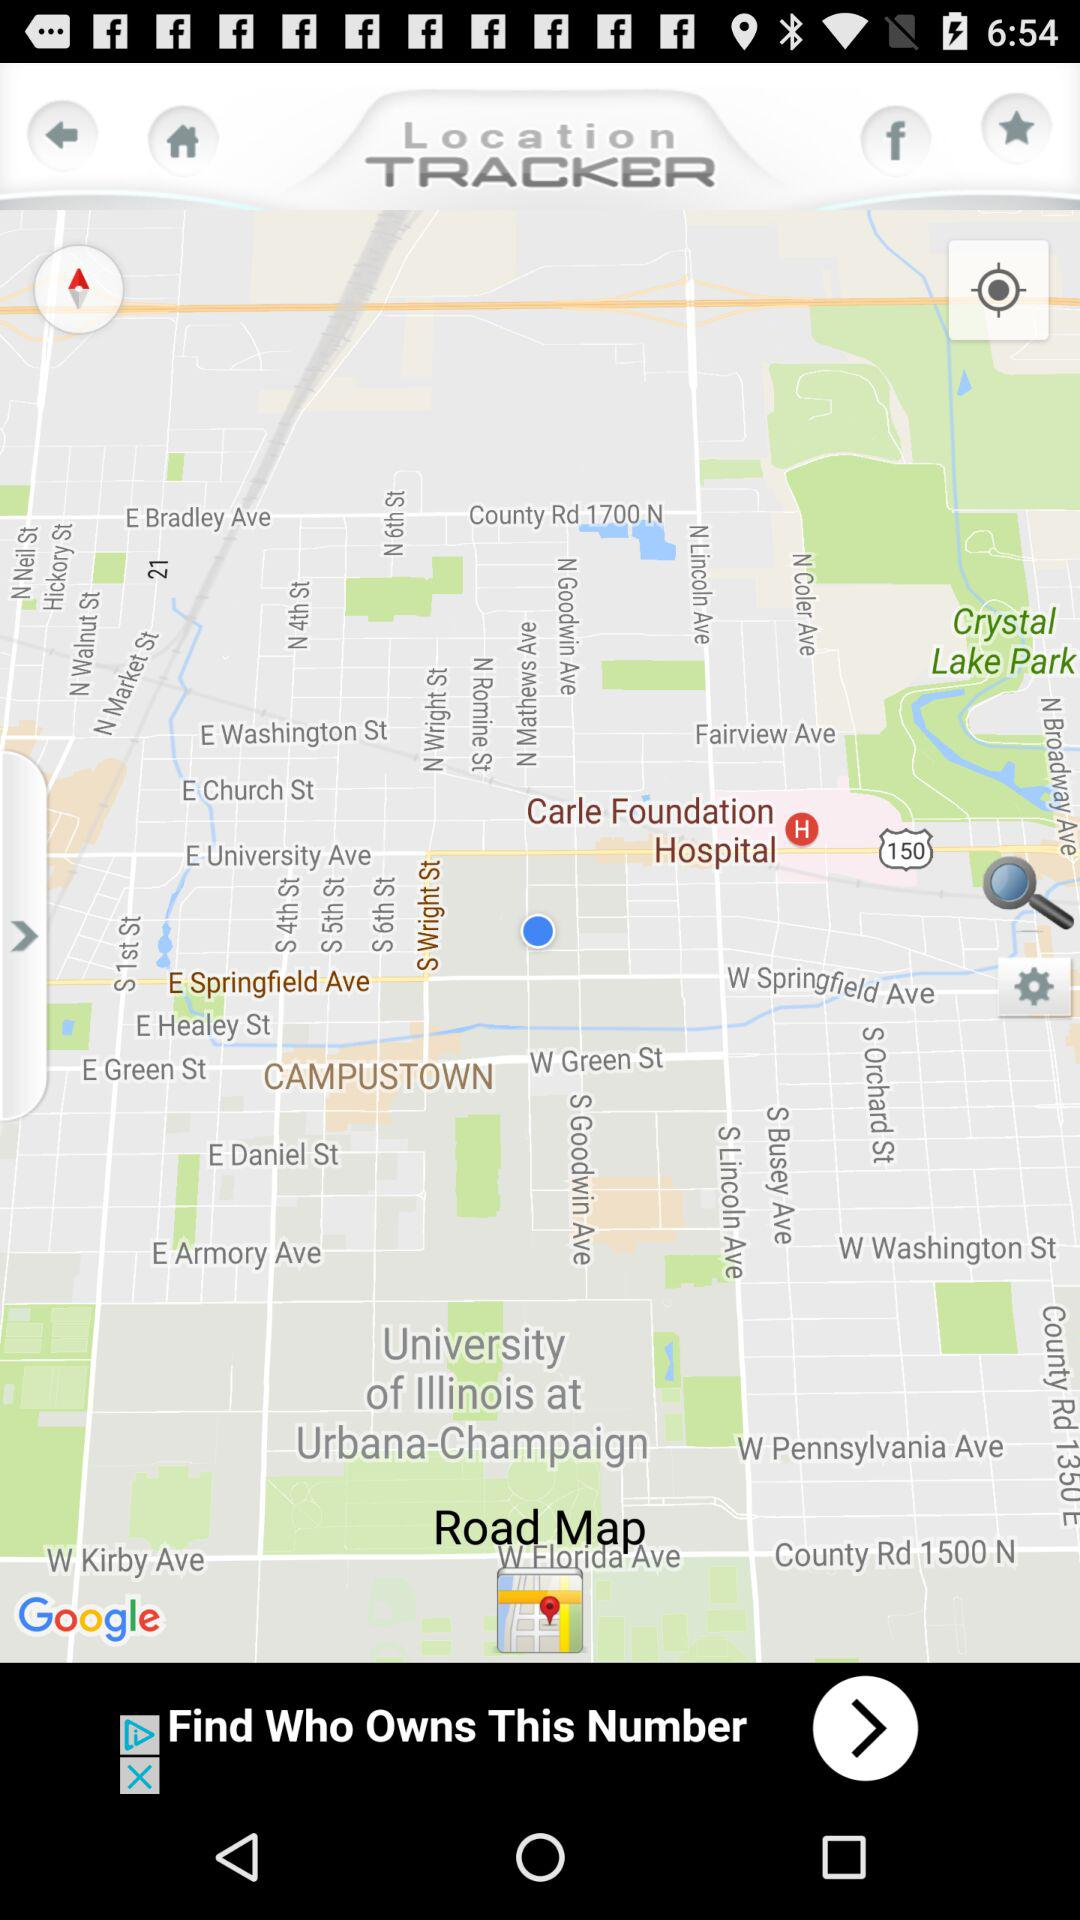What is the name of the application? The name of the application is " Location TRACKER". 